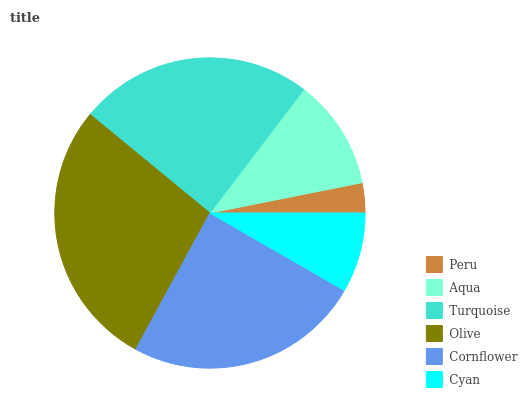Is Peru the minimum?
Answer yes or no. Yes. Is Olive the maximum?
Answer yes or no. Yes. Is Aqua the minimum?
Answer yes or no. No. Is Aqua the maximum?
Answer yes or no. No. Is Aqua greater than Peru?
Answer yes or no. Yes. Is Peru less than Aqua?
Answer yes or no. Yes. Is Peru greater than Aqua?
Answer yes or no. No. Is Aqua less than Peru?
Answer yes or no. No. Is Turquoise the high median?
Answer yes or no. Yes. Is Aqua the low median?
Answer yes or no. Yes. Is Cyan the high median?
Answer yes or no. No. Is Cornflower the low median?
Answer yes or no. No. 